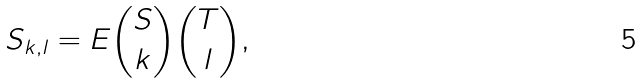Convert formula to latex. <formula><loc_0><loc_0><loc_500><loc_500>S _ { k , l } = { E { { S } \choose k } { { T } \choose l } } ,</formula> 